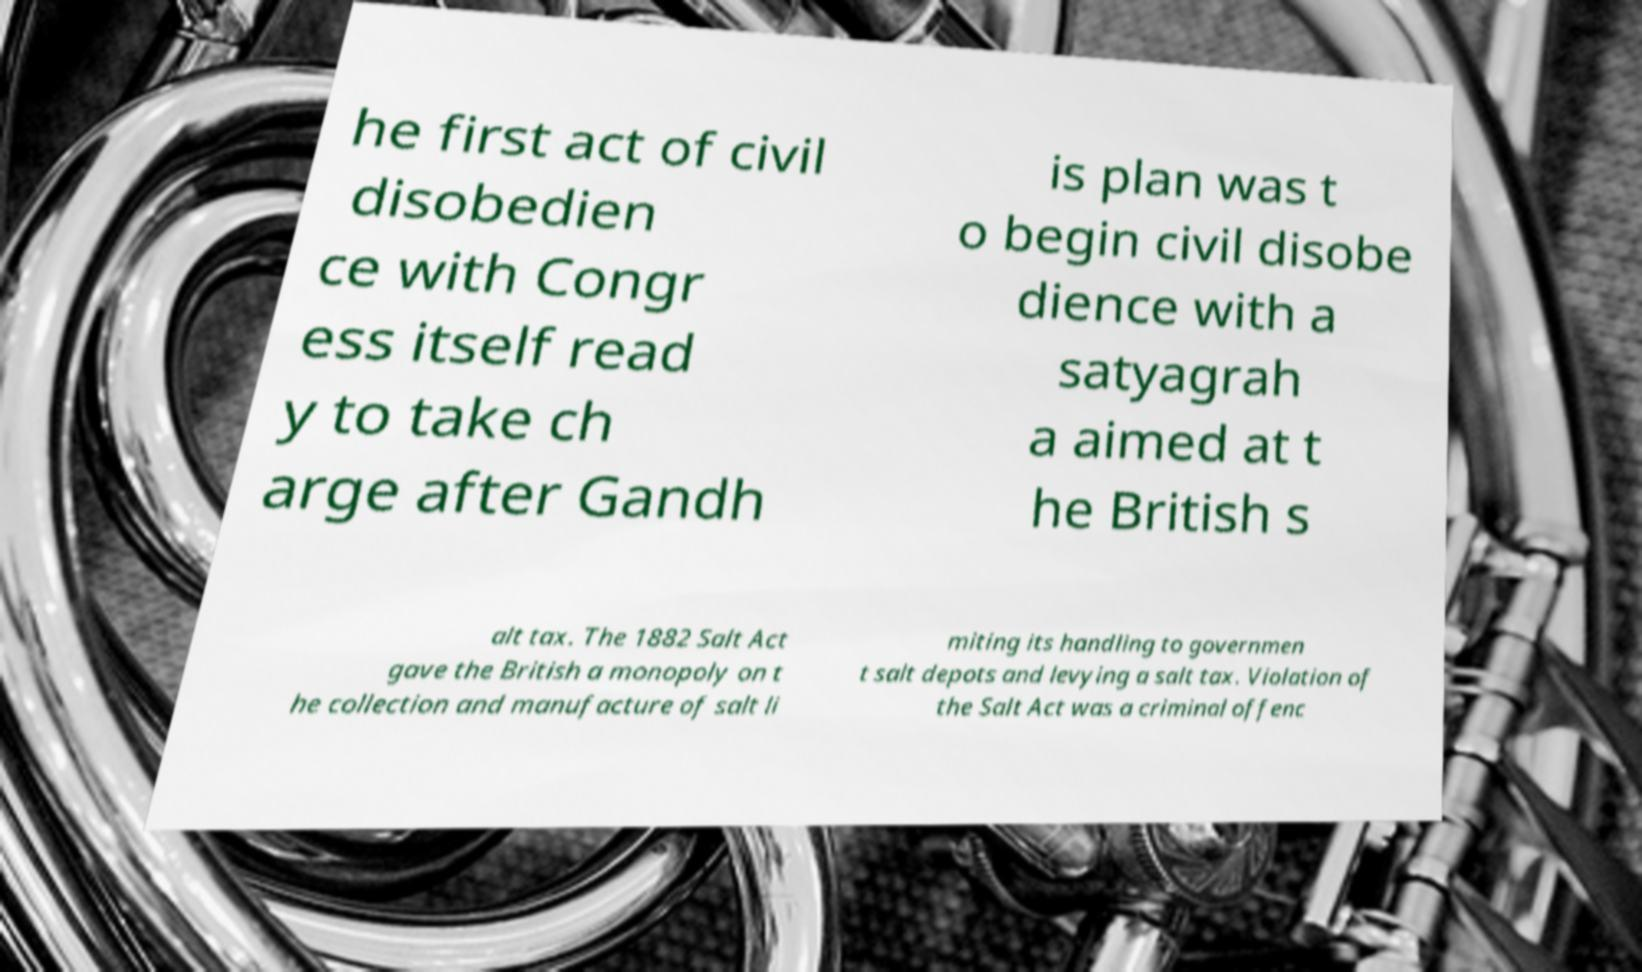What messages or text are displayed in this image? I need them in a readable, typed format. he first act of civil disobedien ce with Congr ess itself read y to take ch arge after Gandh is plan was t o begin civil disobe dience with a satyagrah a aimed at t he British s alt tax. The 1882 Salt Act gave the British a monopoly on t he collection and manufacture of salt li miting its handling to governmen t salt depots and levying a salt tax. Violation of the Salt Act was a criminal offenc 